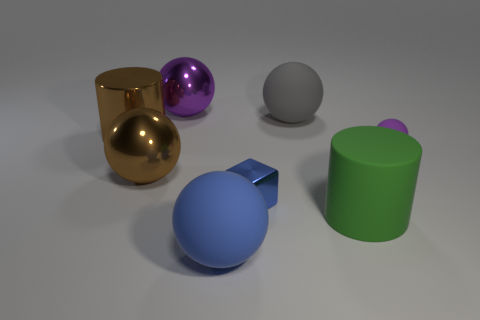Are there any cubes?
Provide a succinct answer. Yes. What is the large thing that is both to the left of the large purple thing and on the right side of the brown metal cylinder made of?
Provide a short and direct response. Metal. Are there more purple spheres to the right of the small blue thing than rubber cylinders behind the large rubber cylinder?
Keep it short and to the point. Yes. Are there any purple metallic balls that have the same size as the green thing?
Your response must be concise. Yes. There is a cylinder that is to the right of the ball that is left of the purple sphere to the left of the tiny metal block; what size is it?
Provide a short and direct response. Large. What color is the small rubber sphere?
Offer a terse response. Purple. Is the number of green objects in front of the big blue ball greater than the number of big purple things?
Keep it short and to the point. No. There is a large brown metal ball; how many large balls are behind it?
Your response must be concise. 2. There is a big thing that is the same color as the tiny ball; what shape is it?
Offer a terse response. Sphere. There is a big cylinder on the right side of the large metal ball behind the small rubber ball; is there a matte thing that is left of it?
Ensure brevity in your answer.  Yes. 